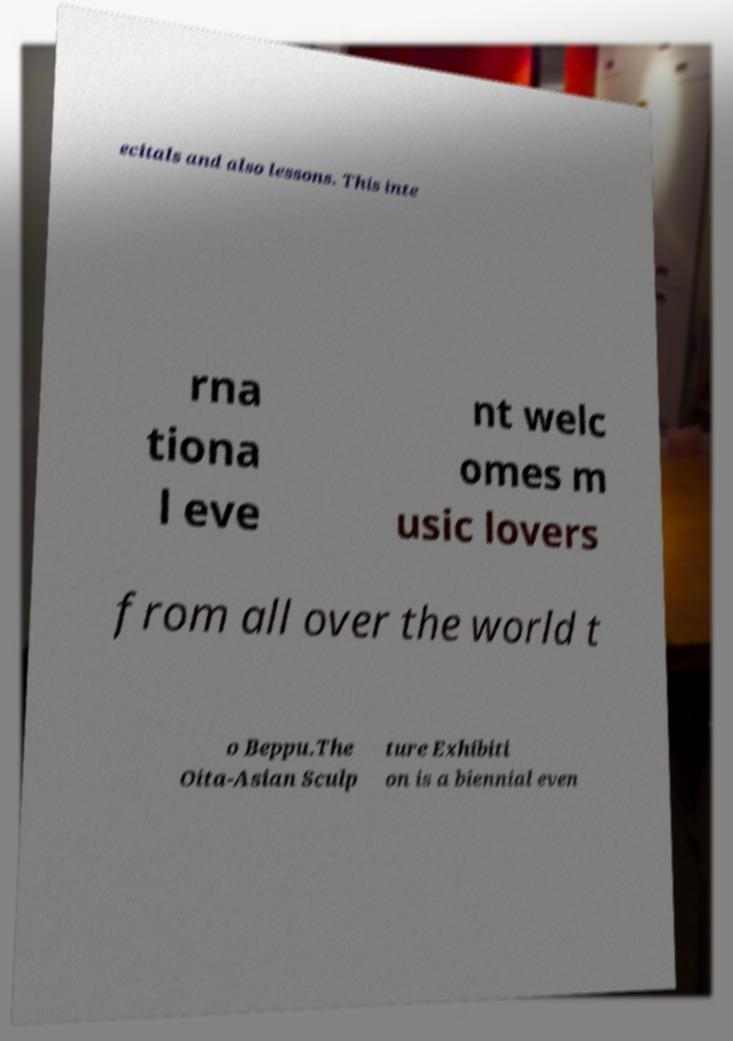There's text embedded in this image that I need extracted. Can you transcribe it verbatim? ecitals and also lessons. This inte rna tiona l eve nt welc omes m usic lovers from all over the world t o Beppu.The Oita-Asian Sculp ture Exhibiti on is a biennial even 